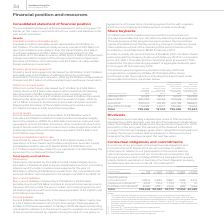According to Vodafone Group Plc's financial document, How many shares were reissued from treasury shares to satisfy the second tranche of the MCB? According to the financial document, 799.1 (in millions). The relevant text states: "n order to satisfy the second tranche of the MCB, 799.1 of million shares were reissued from treasury shares on 25 February 2019 at a conversion price of £..." Also, What unit is the Average price paid per share inclusive of transaction costs expressed in? According to the financial document, Pence. The relevant text states: "ice paid per share inclusive of transaction costs Pence..." Also, When is the share buyback programme expected to be completed? According to the financial document, 20 May 2019. The relevant text states: "d in February 2019 and is expected to complete by 20 May 2019. Details of the shares purchased under the programme, including those purchased under irrevocable i..." Also, can you calculate: What is the percentage change between shares purchased in February and March 2019? To answer this question, I need to perform calculations using the financial data. The calculation is: (305,099-14,529)/14,529, which equals 1999.93 (percentage). This is based on the information: "purchased under the programme 000s February 2019 14,529 135.17 14,529 784,539 March 2019 305,099 140.56 319,628 479,440 April 2019 290,570 142.20 610,198 1 uary 2019 14,529 135.17 14,529 784,539 March..." The key data points involved are: 14,529, 305,099. Also, can you calculate: What is the percentage change between shares purchased in March and April 2019? To answer this question, I need to perform calculations using the financial data. The calculation is: (290,570-305,099)/305,099, which equals -4.76 (percentage). This is based on the information: "ch 2019 305,099 140.56 319,628 479,440 April 2019 290,570 142.20 610,198 188,870 May 2019 (to date) 116,228 140.11 726,426 72,642 Total 726,426 141.04 726,42 uary 2019 14,529 135.17 14,529 784,539 Mar..." The key data points involved are: 290,570, 305,099. Also, can you calculate: What percentage of total shares purchased is the April shares purchased? Based on the calculation: 290,570/726,426, the result is 40 (percentage). This is based on the information: "ch 2019 305,099 140.56 319,628 479,440 April 2019 290,570 142.20 610,198 188,870 May 2019 (to date) 116,228 140.11 726,426 72,642 Total 726,426 141.04 726,42 610,198 188,870 May 2019 (to date) 116,228..." The key data points involved are: 290,570, 726,426. 